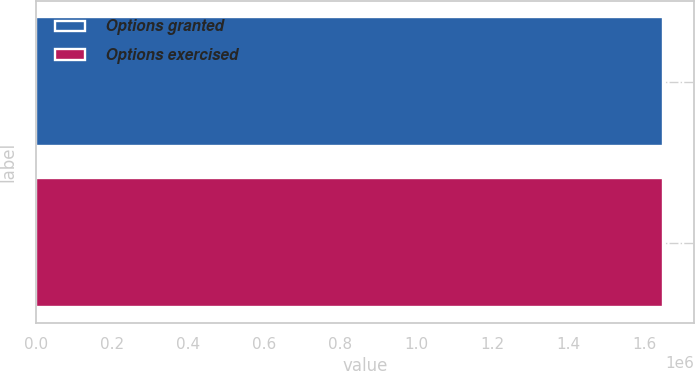Convert chart to OTSL. <chart><loc_0><loc_0><loc_500><loc_500><bar_chart><fcel>Options granted<fcel>Options exercised<nl><fcel>1.64652e+06<fcel>1.64652e+06<nl></chart> 